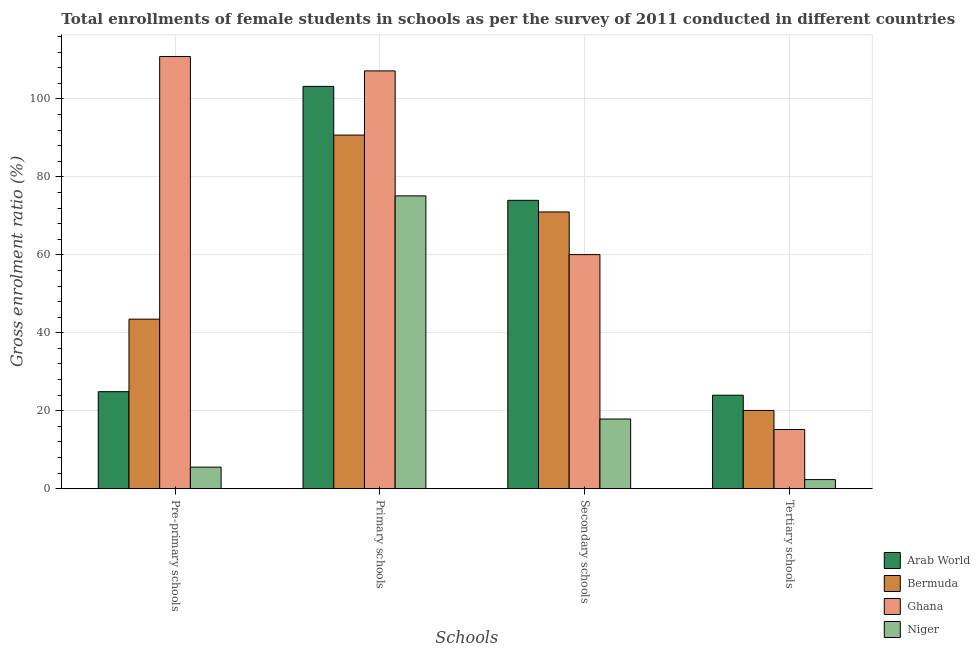How many different coloured bars are there?
Give a very brief answer. 4. How many groups of bars are there?
Ensure brevity in your answer.  4. Are the number of bars per tick equal to the number of legend labels?
Ensure brevity in your answer.  Yes. How many bars are there on the 2nd tick from the left?
Your response must be concise. 4. What is the label of the 2nd group of bars from the left?
Make the answer very short. Primary schools. What is the gross enrolment ratio(female) in primary schools in Arab World?
Offer a very short reply. 103.22. Across all countries, what is the maximum gross enrolment ratio(female) in tertiary schools?
Make the answer very short. 23.98. Across all countries, what is the minimum gross enrolment ratio(female) in tertiary schools?
Offer a terse response. 2.33. In which country was the gross enrolment ratio(female) in tertiary schools maximum?
Ensure brevity in your answer.  Arab World. In which country was the gross enrolment ratio(female) in pre-primary schools minimum?
Make the answer very short. Niger. What is the total gross enrolment ratio(female) in primary schools in the graph?
Your response must be concise. 376.28. What is the difference between the gross enrolment ratio(female) in tertiary schools in Bermuda and that in Niger?
Offer a terse response. 17.75. What is the difference between the gross enrolment ratio(female) in tertiary schools in Ghana and the gross enrolment ratio(female) in secondary schools in Bermuda?
Provide a short and direct response. -55.83. What is the average gross enrolment ratio(female) in secondary schools per country?
Provide a short and direct response. 55.73. What is the difference between the gross enrolment ratio(female) in secondary schools and gross enrolment ratio(female) in tertiary schools in Niger?
Your response must be concise. 15.55. What is the ratio of the gross enrolment ratio(female) in pre-primary schools in Arab World to that in Niger?
Make the answer very short. 4.5. What is the difference between the highest and the second highest gross enrolment ratio(female) in pre-primary schools?
Provide a succinct answer. 67.4. What is the difference between the highest and the lowest gross enrolment ratio(female) in tertiary schools?
Give a very brief answer. 21.66. What does the 3rd bar from the left in Pre-primary schools represents?
Your answer should be compact. Ghana. What does the 1st bar from the right in Primary schools represents?
Offer a very short reply. Niger. Is it the case that in every country, the sum of the gross enrolment ratio(female) in pre-primary schools and gross enrolment ratio(female) in primary schools is greater than the gross enrolment ratio(female) in secondary schools?
Your answer should be very brief. Yes. How many countries are there in the graph?
Keep it short and to the point. 4. What is the difference between two consecutive major ticks on the Y-axis?
Offer a terse response. 20. Does the graph contain any zero values?
Offer a terse response. No. How many legend labels are there?
Offer a terse response. 4. How are the legend labels stacked?
Keep it short and to the point. Vertical. What is the title of the graph?
Provide a short and direct response. Total enrollments of female students in schools as per the survey of 2011 conducted in different countries. What is the label or title of the X-axis?
Your response must be concise. Schools. What is the label or title of the Y-axis?
Offer a very short reply. Gross enrolment ratio (%). What is the Gross enrolment ratio (%) of Arab World in Pre-primary schools?
Offer a terse response. 24.89. What is the Gross enrolment ratio (%) in Bermuda in Pre-primary schools?
Keep it short and to the point. 43.5. What is the Gross enrolment ratio (%) of Ghana in Pre-primary schools?
Provide a succinct answer. 110.9. What is the Gross enrolment ratio (%) of Niger in Pre-primary schools?
Provide a succinct answer. 5.53. What is the Gross enrolment ratio (%) of Arab World in Primary schools?
Offer a terse response. 103.22. What is the Gross enrolment ratio (%) in Bermuda in Primary schools?
Keep it short and to the point. 90.73. What is the Gross enrolment ratio (%) of Ghana in Primary schools?
Provide a succinct answer. 107.2. What is the Gross enrolment ratio (%) in Niger in Primary schools?
Your answer should be compact. 75.13. What is the Gross enrolment ratio (%) in Arab World in Secondary schools?
Provide a short and direct response. 73.99. What is the Gross enrolment ratio (%) of Bermuda in Secondary schools?
Ensure brevity in your answer.  71.01. What is the Gross enrolment ratio (%) in Ghana in Secondary schools?
Offer a terse response. 60.06. What is the Gross enrolment ratio (%) of Niger in Secondary schools?
Provide a short and direct response. 17.88. What is the Gross enrolment ratio (%) in Arab World in Tertiary schools?
Give a very brief answer. 23.98. What is the Gross enrolment ratio (%) in Bermuda in Tertiary schools?
Make the answer very short. 20.08. What is the Gross enrolment ratio (%) in Ghana in Tertiary schools?
Offer a very short reply. 15.18. What is the Gross enrolment ratio (%) of Niger in Tertiary schools?
Your response must be concise. 2.33. Across all Schools, what is the maximum Gross enrolment ratio (%) of Arab World?
Your response must be concise. 103.22. Across all Schools, what is the maximum Gross enrolment ratio (%) of Bermuda?
Your answer should be compact. 90.73. Across all Schools, what is the maximum Gross enrolment ratio (%) of Ghana?
Your answer should be very brief. 110.9. Across all Schools, what is the maximum Gross enrolment ratio (%) in Niger?
Your answer should be compact. 75.13. Across all Schools, what is the minimum Gross enrolment ratio (%) of Arab World?
Provide a short and direct response. 23.98. Across all Schools, what is the minimum Gross enrolment ratio (%) of Bermuda?
Give a very brief answer. 20.08. Across all Schools, what is the minimum Gross enrolment ratio (%) in Ghana?
Provide a succinct answer. 15.18. Across all Schools, what is the minimum Gross enrolment ratio (%) of Niger?
Give a very brief answer. 2.33. What is the total Gross enrolment ratio (%) of Arab World in the graph?
Make the answer very short. 226.08. What is the total Gross enrolment ratio (%) of Bermuda in the graph?
Provide a succinct answer. 225.31. What is the total Gross enrolment ratio (%) in Ghana in the graph?
Offer a terse response. 293.34. What is the total Gross enrolment ratio (%) in Niger in the graph?
Provide a succinct answer. 100.86. What is the difference between the Gross enrolment ratio (%) of Arab World in Pre-primary schools and that in Primary schools?
Keep it short and to the point. -78.33. What is the difference between the Gross enrolment ratio (%) in Bermuda in Pre-primary schools and that in Primary schools?
Offer a terse response. -47.23. What is the difference between the Gross enrolment ratio (%) of Ghana in Pre-primary schools and that in Primary schools?
Your response must be concise. 3.69. What is the difference between the Gross enrolment ratio (%) in Niger in Pre-primary schools and that in Primary schools?
Offer a terse response. -69.59. What is the difference between the Gross enrolment ratio (%) in Arab World in Pre-primary schools and that in Secondary schools?
Keep it short and to the point. -49.1. What is the difference between the Gross enrolment ratio (%) in Bermuda in Pre-primary schools and that in Secondary schools?
Your answer should be very brief. -27.51. What is the difference between the Gross enrolment ratio (%) of Ghana in Pre-primary schools and that in Secondary schools?
Keep it short and to the point. 50.83. What is the difference between the Gross enrolment ratio (%) of Niger in Pre-primary schools and that in Secondary schools?
Your answer should be compact. -12.34. What is the difference between the Gross enrolment ratio (%) in Arab World in Pre-primary schools and that in Tertiary schools?
Your answer should be very brief. 0.91. What is the difference between the Gross enrolment ratio (%) of Bermuda in Pre-primary schools and that in Tertiary schools?
Your answer should be compact. 23.42. What is the difference between the Gross enrolment ratio (%) of Ghana in Pre-primary schools and that in Tertiary schools?
Offer a terse response. 95.72. What is the difference between the Gross enrolment ratio (%) in Niger in Pre-primary schools and that in Tertiary schools?
Your answer should be very brief. 3.2. What is the difference between the Gross enrolment ratio (%) of Arab World in Primary schools and that in Secondary schools?
Keep it short and to the point. 29.23. What is the difference between the Gross enrolment ratio (%) in Bermuda in Primary schools and that in Secondary schools?
Ensure brevity in your answer.  19.73. What is the difference between the Gross enrolment ratio (%) in Ghana in Primary schools and that in Secondary schools?
Make the answer very short. 47.14. What is the difference between the Gross enrolment ratio (%) in Niger in Primary schools and that in Secondary schools?
Keep it short and to the point. 57.25. What is the difference between the Gross enrolment ratio (%) of Arab World in Primary schools and that in Tertiary schools?
Make the answer very short. 79.24. What is the difference between the Gross enrolment ratio (%) in Bermuda in Primary schools and that in Tertiary schools?
Keep it short and to the point. 70.66. What is the difference between the Gross enrolment ratio (%) of Ghana in Primary schools and that in Tertiary schools?
Your answer should be very brief. 92.02. What is the difference between the Gross enrolment ratio (%) of Niger in Primary schools and that in Tertiary schools?
Give a very brief answer. 72.8. What is the difference between the Gross enrolment ratio (%) in Arab World in Secondary schools and that in Tertiary schools?
Your answer should be very brief. 50. What is the difference between the Gross enrolment ratio (%) of Bermuda in Secondary schools and that in Tertiary schools?
Your answer should be very brief. 50.93. What is the difference between the Gross enrolment ratio (%) of Ghana in Secondary schools and that in Tertiary schools?
Provide a succinct answer. 44.88. What is the difference between the Gross enrolment ratio (%) in Niger in Secondary schools and that in Tertiary schools?
Give a very brief answer. 15.55. What is the difference between the Gross enrolment ratio (%) in Arab World in Pre-primary schools and the Gross enrolment ratio (%) in Bermuda in Primary schools?
Provide a short and direct response. -65.84. What is the difference between the Gross enrolment ratio (%) of Arab World in Pre-primary schools and the Gross enrolment ratio (%) of Ghana in Primary schools?
Provide a short and direct response. -82.31. What is the difference between the Gross enrolment ratio (%) of Arab World in Pre-primary schools and the Gross enrolment ratio (%) of Niger in Primary schools?
Your answer should be compact. -50.24. What is the difference between the Gross enrolment ratio (%) of Bermuda in Pre-primary schools and the Gross enrolment ratio (%) of Ghana in Primary schools?
Provide a short and direct response. -63.7. What is the difference between the Gross enrolment ratio (%) of Bermuda in Pre-primary schools and the Gross enrolment ratio (%) of Niger in Primary schools?
Provide a short and direct response. -31.63. What is the difference between the Gross enrolment ratio (%) of Ghana in Pre-primary schools and the Gross enrolment ratio (%) of Niger in Primary schools?
Provide a succinct answer. 35.77. What is the difference between the Gross enrolment ratio (%) of Arab World in Pre-primary schools and the Gross enrolment ratio (%) of Bermuda in Secondary schools?
Offer a very short reply. -46.12. What is the difference between the Gross enrolment ratio (%) in Arab World in Pre-primary schools and the Gross enrolment ratio (%) in Ghana in Secondary schools?
Ensure brevity in your answer.  -35.17. What is the difference between the Gross enrolment ratio (%) in Arab World in Pre-primary schools and the Gross enrolment ratio (%) in Niger in Secondary schools?
Keep it short and to the point. 7.01. What is the difference between the Gross enrolment ratio (%) of Bermuda in Pre-primary schools and the Gross enrolment ratio (%) of Ghana in Secondary schools?
Your answer should be very brief. -16.56. What is the difference between the Gross enrolment ratio (%) of Bermuda in Pre-primary schools and the Gross enrolment ratio (%) of Niger in Secondary schools?
Your answer should be very brief. 25.62. What is the difference between the Gross enrolment ratio (%) in Ghana in Pre-primary schools and the Gross enrolment ratio (%) in Niger in Secondary schools?
Your answer should be compact. 93.02. What is the difference between the Gross enrolment ratio (%) in Arab World in Pre-primary schools and the Gross enrolment ratio (%) in Bermuda in Tertiary schools?
Make the answer very short. 4.81. What is the difference between the Gross enrolment ratio (%) in Arab World in Pre-primary schools and the Gross enrolment ratio (%) in Ghana in Tertiary schools?
Make the answer very short. 9.71. What is the difference between the Gross enrolment ratio (%) of Arab World in Pre-primary schools and the Gross enrolment ratio (%) of Niger in Tertiary schools?
Your response must be concise. 22.56. What is the difference between the Gross enrolment ratio (%) of Bermuda in Pre-primary schools and the Gross enrolment ratio (%) of Ghana in Tertiary schools?
Your response must be concise. 28.32. What is the difference between the Gross enrolment ratio (%) of Bermuda in Pre-primary schools and the Gross enrolment ratio (%) of Niger in Tertiary schools?
Keep it short and to the point. 41.17. What is the difference between the Gross enrolment ratio (%) in Ghana in Pre-primary schools and the Gross enrolment ratio (%) in Niger in Tertiary schools?
Offer a very short reply. 108.57. What is the difference between the Gross enrolment ratio (%) in Arab World in Primary schools and the Gross enrolment ratio (%) in Bermuda in Secondary schools?
Your response must be concise. 32.22. What is the difference between the Gross enrolment ratio (%) of Arab World in Primary schools and the Gross enrolment ratio (%) of Ghana in Secondary schools?
Offer a terse response. 43.16. What is the difference between the Gross enrolment ratio (%) of Arab World in Primary schools and the Gross enrolment ratio (%) of Niger in Secondary schools?
Your answer should be very brief. 85.35. What is the difference between the Gross enrolment ratio (%) in Bermuda in Primary schools and the Gross enrolment ratio (%) in Ghana in Secondary schools?
Offer a terse response. 30.67. What is the difference between the Gross enrolment ratio (%) in Bermuda in Primary schools and the Gross enrolment ratio (%) in Niger in Secondary schools?
Ensure brevity in your answer.  72.86. What is the difference between the Gross enrolment ratio (%) of Ghana in Primary schools and the Gross enrolment ratio (%) of Niger in Secondary schools?
Provide a short and direct response. 89.32. What is the difference between the Gross enrolment ratio (%) of Arab World in Primary schools and the Gross enrolment ratio (%) of Bermuda in Tertiary schools?
Your answer should be very brief. 83.15. What is the difference between the Gross enrolment ratio (%) in Arab World in Primary schools and the Gross enrolment ratio (%) in Ghana in Tertiary schools?
Offer a terse response. 88.04. What is the difference between the Gross enrolment ratio (%) of Arab World in Primary schools and the Gross enrolment ratio (%) of Niger in Tertiary schools?
Give a very brief answer. 100.9. What is the difference between the Gross enrolment ratio (%) in Bermuda in Primary schools and the Gross enrolment ratio (%) in Ghana in Tertiary schools?
Keep it short and to the point. 75.55. What is the difference between the Gross enrolment ratio (%) in Bermuda in Primary schools and the Gross enrolment ratio (%) in Niger in Tertiary schools?
Keep it short and to the point. 88.41. What is the difference between the Gross enrolment ratio (%) in Ghana in Primary schools and the Gross enrolment ratio (%) in Niger in Tertiary schools?
Offer a terse response. 104.87. What is the difference between the Gross enrolment ratio (%) of Arab World in Secondary schools and the Gross enrolment ratio (%) of Bermuda in Tertiary schools?
Provide a succinct answer. 53.91. What is the difference between the Gross enrolment ratio (%) in Arab World in Secondary schools and the Gross enrolment ratio (%) in Ghana in Tertiary schools?
Ensure brevity in your answer.  58.81. What is the difference between the Gross enrolment ratio (%) in Arab World in Secondary schools and the Gross enrolment ratio (%) in Niger in Tertiary schools?
Ensure brevity in your answer.  71.66. What is the difference between the Gross enrolment ratio (%) of Bermuda in Secondary schools and the Gross enrolment ratio (%) of Ghana in Tertiary schools?
Your answer should be compact. 55.83. What is the difference between the Gross enrolment ratio (%) in Bermuda in Secondary schools and the Gross enrolment ratio (%) in Niger in Tertiary schools?
Provide a succinct answer. 68.68. What is the difference between the Gross enrolment ratio (%) of Ghana in Secondary schools and the Gross enrolment ratio (%) of Niger in Tertiary schools?
Make the answer very short. 57.73. What is the average Gross enrolment ratio (%) of Arab World per Schools?
Your response must be concise. 56.52. What is the average Gross enrolment ratio (%) in Bermuda per Schools?
Give a very brief answer. 56.33. What is the average Gross enrolment ratio (%) of Ghana per Schools?
Provide a succinct answer. 73.33. What is the average Gross enrolment ratio (%) of Niger per Schools?
Your response must be concise. 25.21. What is the difference between the Gross enrolment ratio (%) in Arab World and Gross enrolment ratio (%) in Bermuda in Pre-primary schools?
Provide a short and direct response. -18.61. What is the difference between the Gross enrolment ratio (%) in Arab World and Gross enrolment ratio (%) in Ghana in Pre-primary schools?
Ensure brevity in your answer.  -86.01. What is the difference between the Gross enrolment ratio (%) in Arab World and Gross enrolment ratio (%) in Niger in Pre-primary schools?
Give a very brief answer. 19.36. What is the difference between the Gross enrolment ratio (%) of Bermuda and Gross enrolment ratio (%) of Ghana in Pre-primary schools?
Your response must be concise. -67.4. What is the difference between the Gross enrolment ratio (%) in Bermuda and Gross enrolment ratio (%) in Niger in Pre-primary schools?
Your answer should be very brief. 37.97. What is the difference between the Gross enrolment ratio (%) of Ghana and Gross enrolment ratio (%) of Niger in Pre-primary schools?
Your answer should be compact. 105.36. What is the difference between the Gross enrolment ratio (%) in Arab World and Gross enrolment ratio (%) in Bermuda in Primary schools?
Give a very brief answer. 12.49. What is the difference between the Gross enrolment ratio (%) of Arab World and Gross enrolment ratio (%) of Ghana in Primary schools?
Provide a short and direct response. -3.98. What is the difference between the Gross enrolment ratio (%) of Arab World and Gross enrolment ratio (%) of Niger in Primary schools?
Ensure brevity in your answer.  28.1. What is the difference between the Gross enrolment ratio (%) in Bermuda and Gross enrolment ratio (%) in Ghana in Primary schools?
Offer a terse response. -16.47. What is the difference between the Gross enrolment ratio (%) in Bermuda and Gross enrolment ratio (%) in Niger in Primary schools?
Ensure brevity in your answer.  15.61. What is the difference between the Gross enrolment ratio (%) of Ghana and Gross enrolment ratio (%) of Niger in Primary schools?
Provide a succinct answer. 32.07. What is the difference between the Gross enrolment ratio (%) of Arab World and Gross enrolment ratio (%) of Bermuda in Secondary schools?
Your answer should be very brief. 2.98. What is the difference between the Gross enrolment ratio (%) in Arab World and Gross enrolment ratio (%) in Ghana in Secondary schools?
Offer a terse response. 13.93. What is the difference between the Gross enrolment ratio (%) in Arab World and Gross enrolment ratio (%) in Niger in Secondary schools?
Your response must be concise. 56.11. What is the difference between the Gross enrolment ratio (%) of Bermuda and Gross enrolment ratio (%) of Ghana in Secondary schools?
Make the answer very short. 10.95. What is the difference between the Gross enrolment ratio (%) in Bermuda and Gross enrolment ratio (%) in Niger in Secondary schools?
Make the answer very short. 53.13. What is the difference between the Gross enrolment ratio (%) in Ghana and Gross enrolment ratio (%) in Niger in Secondary schools?
Offer a very short reply. 42.19. What is the difference between the Gross enrolment ratio (%) in Arab World and Gross enrolment ratio (%) in Bermuda in Tertiary schools?
Make the answer very short. 3.91. What is the difference between the Gross enrolment ratio (%) in Arab World and Gross enrolment ratio (%) in Ghana in Tertiary schools?
Your response must be concise. 8.81. What is the difference between the Gross enrolment ratio (%) of Arab World and Gross enrolment ratio (%) of Niger in Tertiary schools?
Offer a terse response. 21.66. What is the difference between the Gross enrolment ratio (%) of Bermuda and Gross enrolment ratio (%) of Ghana in Tertiary schools?
Offer a terse response. 4.9. What is the difference between the Gross enrolment ratio (%) in Bermuda and Gross enrolment ratio (%) in Niger in Tertiary schools?
Your response must be concise. 17.75. What is the difference between the Gross enrolment ratio (%) of Ghana and Gross enrolment ratio (%) of Niger in Tertiary schools?
Offer a very short reply. 12.85. What is the ratio of the Gross enrolment ratio (%) in Arab World in Pre-primary schools to that in Primary schools?
Provide a succinct answer. 0.24. What is the ratio of the Gross enrolment ratio (%) of Bermuda in Pre-primary schools to that in Primary schools?
Offer a very short reply. 0.48. What is the ratio of the Gross enrolment ratio (%) in Ghana in Pre-primary schools to that in Primary schools?
Your response must be concise. 1.03. What is the ratio of the Gross enrolment ratio (%) in Niger in Pre-primary schools to that in Primary schools?
Your response must be concise. 0.07. What is the ratio of the Gross enrolment ratio (%) of Arab World in Pre-primary schools to that in Secondary schools?
Make the answer very short. 0.34. What is the ratio of the Gross enrolment ratio (%) of Bermuda in Pre-primary schools to that in Secondary schools?
Your answer should be very brief. 0.61. What is the ratio of the Gross enrolment ratio (%) in Ghana in Pre-primary schools to that in Secondary schools?
Ensure brevity in your answer.  1.85. What is the ratio of the Gross enrolment ratio (%) of Niger in Pre-primary schools to that in Secondary schools?
Offer a very short reply. 0.31. What is the ratio of the Gross enrolment ratio (%) in Arab World in Pre-primary schools to that in Tertiary schools?
Keep it short and to the point. 1.04. What is the ratio of the Gross enrolment ratio (%) of Bermuda in Pre-primary schools to that in Tertiary schools?
Your answer should be very brief. 2.17. What is the ratio of the Gross enrolment ratio (%) of Ghana in Pre-primary schools to that in Tertiary schools?
Your answer should be compact. 7.31. What is the ratio of the Gross enrolment ratio (%) in Niger in Pre-primary schools to that in Tertiary schools?
Offer a terse response. 2.38. What is the ratio of the Gross enrolment ratio (%) of Arab World in Primary schools to that in Secondary schools?
Your answer should be very brief. 1.4. What is the ratio of the Gross enrolment ratio (%) of Bermuda in Primary schools to that in Secondary schools?
Provide a succinct answer. 1.28. What is the ratio of the Gross enrolment ratio (%) in Ghana in Primary schools to that in Secondary schools?
Make the answer very short. 1.78. What is the ratio of the Gross enrolment ratio (%) in Niger in Primary schools to that in Secondary schools?
Offer a terse response. 4.2. What is the ratio of the Gross enrolment ratio (%) in Arab World in Primary schools to that in Tertiary schools?
Provide a succinct answer. 4.3. What is the ratio of the Gross enrolment ratio (%) of Bermuda in Primary schools to that in Tertiary schools?
Provide a short and direct response. 4.52. What is the ratio of the Gross enrolment ratio (%) of Ghana in Primary schools to that in Tertiary schools?
Offer a very short reply. 7.06. What is the ratio of the Gross enrolment ratio (%) in Niger in Primary schools to that in Tertiary schools?
Your answer should be very brief. 32.29. What is the ratio of the Gross enrolment ratio (%) in Arab World in Secondary schools to that in Tertiary schools?
Your response must be concise. 3.08. What is the ratio of the Gross enrolment ratio (%) in Bermuda in Secondary schools to that in Tertiary schools?
Your answer should be compact. 3.54. What is the ratio of the Gross enrolment ratio (%) of Ghana in Secondary schools to that in Tertiary schools?
Offer a very short reply. 3.96. What is the ratio of the Gross enrolment ratio (%) of Niger in Secondary schools to that in Tertiary schools?
Make the answer very short. 7.68. What is the difference between the highest and the second highest Gross enrolment ratio (%) in Arab World?
Provide a succinct answer. 29.23. What is the difference between the highest and the second highest Gross enrolment ratio (%) in Bermuda?
Your answer should be compact. 19.73. What is the difference between the highest and the second highest Gross enrolment ratio (%) of Ghana?
Your answer should be very brief. 3.69. What is the difference between the highest and the second highest Gross enrolment ratio (%) in Niger?
Your response must be concise. 57.25. What is the difference between the highest and the lowest Gross enrolment ratio (%) in Arab World?
Your response must be concise. 79.24. What is the difference between the highest and the lowest Gross enrolment ratio (%) in Bermuda?
Your response must be concise. 70.66. What is the difference between the highest and the lowest Gross enrolment ratio (%) of Ghana?
Provide a short and direct response. 95.72. What is the difference between the highest and the lowest Gross enrolment ratio (%) in Niger?
Keep it short and to the point. 72.8. 